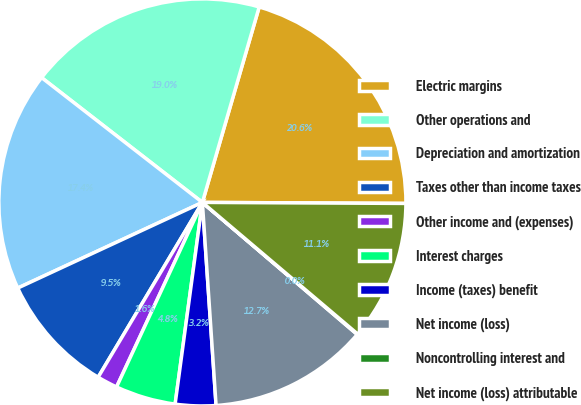<chart> <loc_0><loc_0><loc_500><loc_500><pie_chart><fcel>Electric margins<fcel>Other operations and<fcel>Depreciation and amortization<fcel>Taxes other than income taxes<fcel>Other income and (expenses)<fcel>Interest charges<fcel>Income (taxes) benefit<fcel>Net income (loss)<fcel>Noncontrolling interest and<fcel>Net income (loss) attributable<nl><fcel>20.58%<fcel>19.0%<fcel>17.42%<fcel>9.53%<fcel>1.63%<fcel>4.79%<fcel>3.21%<fcel>12.69%<fcel>0.05%<fcel>11.11%<nl></chart> 